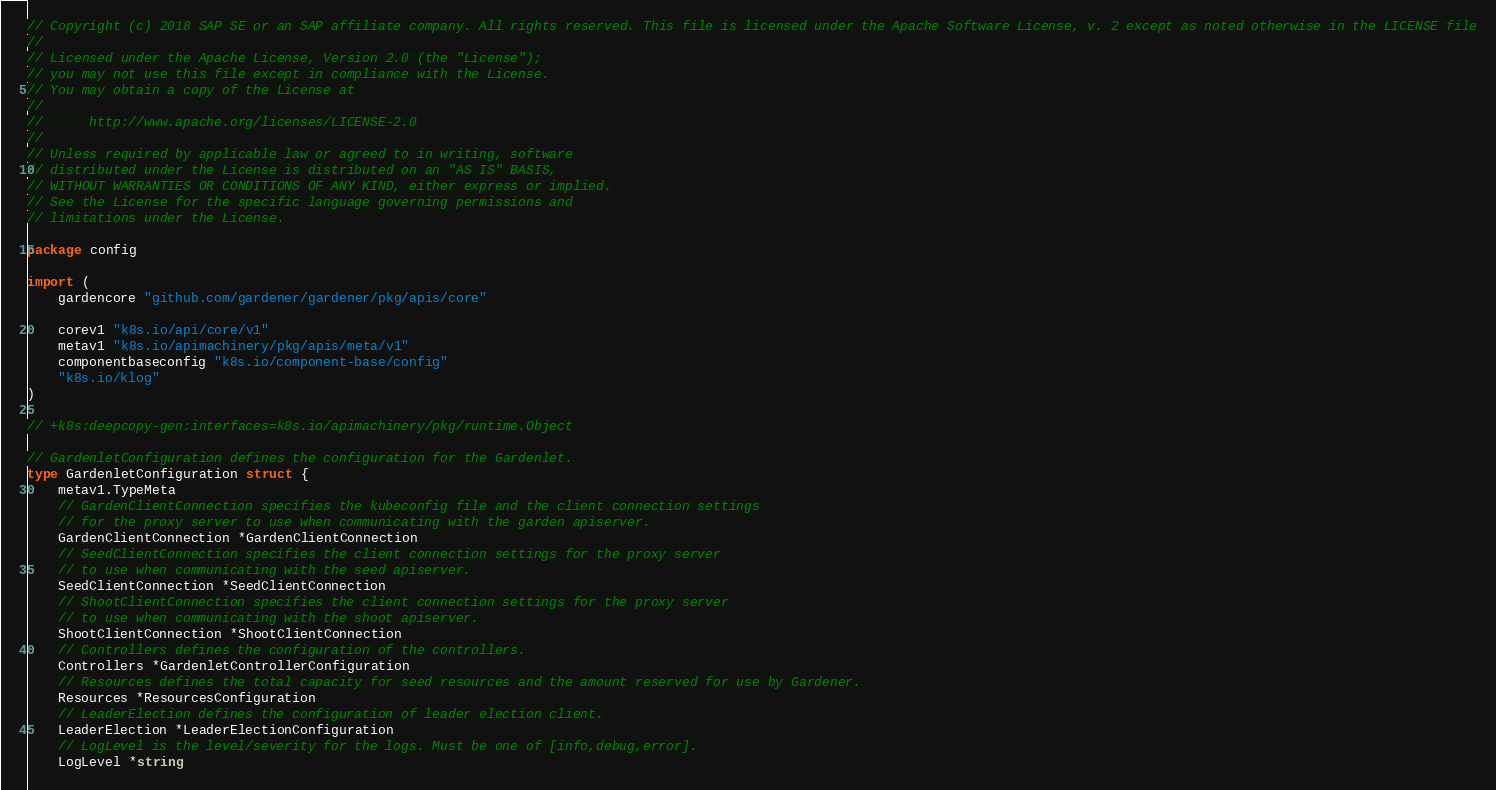<code> <loc_0><loc_0><loc_500><loc_500><_Go_>// Copyright (c) 2018 SAP SE or an SAP affiliate company. All rights reserved. This file is licensed under the Apache Software License, v. 2 except as noted otherwise in the LICENSE file
//
// Licensed under the Apache License, Version 2.0 (the "License");
// you may not use this file except in compliance with the License.
// You may obtain a copy of the License at
//
//      http://www.apache.org/licenses/LICENSE-2.0
//
// Unless required by applicable law or agreed to in writing, software
// distributed under the License is distributed on an "AS IS" BASIS,
// WITHOUT WARRANTIES OR CONDITIONS OF ANY KIND, either express or implied.
// See the License for the specific language governing permissions and
// limitations under the License.

package config

import (
	gardencore "github.com/gardener/gardener/pkg/apis/core"

	corev1 "k8s.io/api/core/v1"
	metav1 "k8s.io/apimachinery/pkg/apis/meta/v1"
	componentbaseconfig "k8s.io/component-base/config"
	"k8s.io/klog"
)

// +k8s:deepcopy-gen:interfaces=k8s.io/apimachinery/pkg/runtime.Object

// GardenletConfiguration defines the configuration for the Gardenlet.
type GardenletConfiguration struct {
	metav1.TypeMeta
	// GardenClientConnection specifies the kubeconfig file and the client connection settings
	// for the proxy server to use when communicating with the garden apiserver.
	GardenClientConnection *GardenClientConnection
	// SeedClientConnection specifies the client connection settings for the proxy server
	// to use when communicating with the seed apiserver.
	SeedClientConnection *SeedClientConnection
	// ShootClientConnection specifies the client connection settings for the proxy server
	// to use when communicating with the shoot apiserver.
	ShootClientConnection *ShootClientConnection
	// Controllers defines the configuration of the controllers.
	Controllers *GardenletControllerConfiguration
	// Resources defines the total capacity for seed resources and the amount reserved for use by Gardener.
	Resources *ResourcesConfiguration
	// LeaderElection defines the configuration of leader election client.
	LeaderElection *LeaderElectionConfiguration
	// LogLevel is the level/severity for the logs. Must be one of [info,debug,error].
	LogLevel *string</code> 